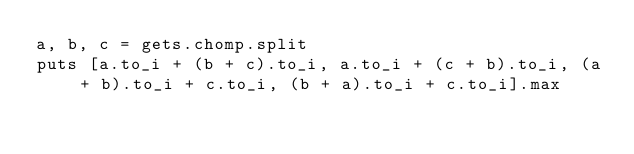<code> <loc_0><loc_0><loc_500><loc_500><_Ruby_>a, b, c = gets.chomp.split
puts [a.to_i + (b + c).to_i, a.to_i + (c + b).to_i, (a + b).to_i + c.to_i, (b + a).to_i + c.to_i].max</code> 